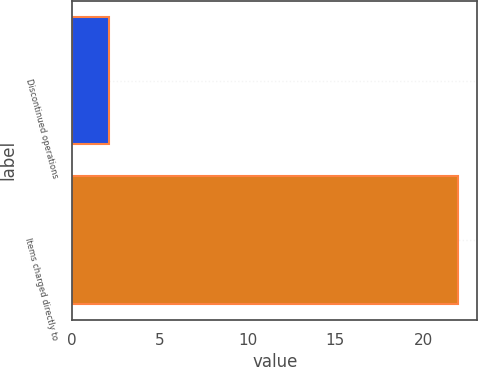Convert chart to OTSL. <chart><loc_0><loc_0><loc_500><loc_500><bar_chart><fcel>Discontinued operations<fcel>Items charged directly to<nl><fcel>2.1<fcel>22<nl></chart> 